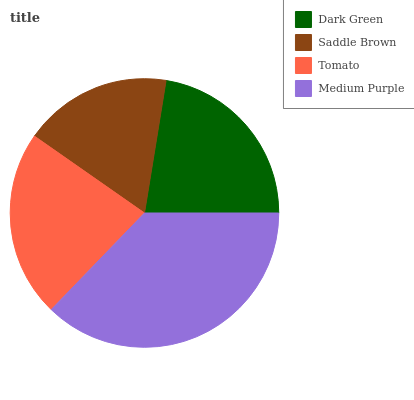Is Saddle Brown the minimum?
Answer yes or no. Yes. Is Medium Purple the maximum?
Answer yes or no. Yes. Is Tomato the minimum?
Answer yes or no. No. Is Tomato the maximum?
Answer yes or no. No. Is Tomato greater than Saddle Brown?
Answer yes or no. Yes. Is Saddle Brown less than Tomato?
Answer yes or no. Yes. Is Saddle Brown greater than Tomato?
Answer yes or no. No. Is Tomato less than Saddle Brown?
Answer yes or no. No. Is Tomato the high median?
Answer yes or no. Yes. Is Dark Green the low median?
Answer yes or no. Yes. Is Saddle Brown the high median?
Answer yes or no. No. Is Tomato the low median?
Answer yes or no. No. 